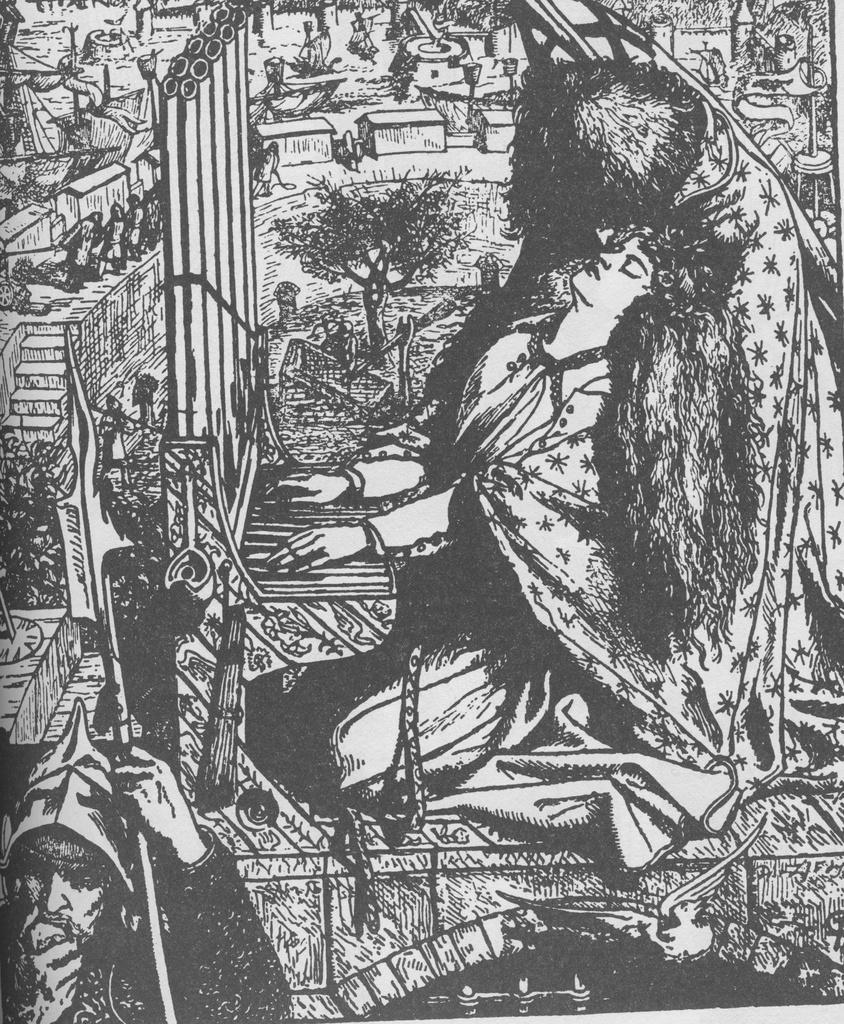Can you describe this image briefly? In the picture I can see the illustration art image. In the picture I can see the art of a woman and looks like she is playing a musical instrument. There is a man on the bottom left side of the picture. I can see the art of a few people on the road on the top left side. It is looking like a bird on the bottom right side of the picture. 